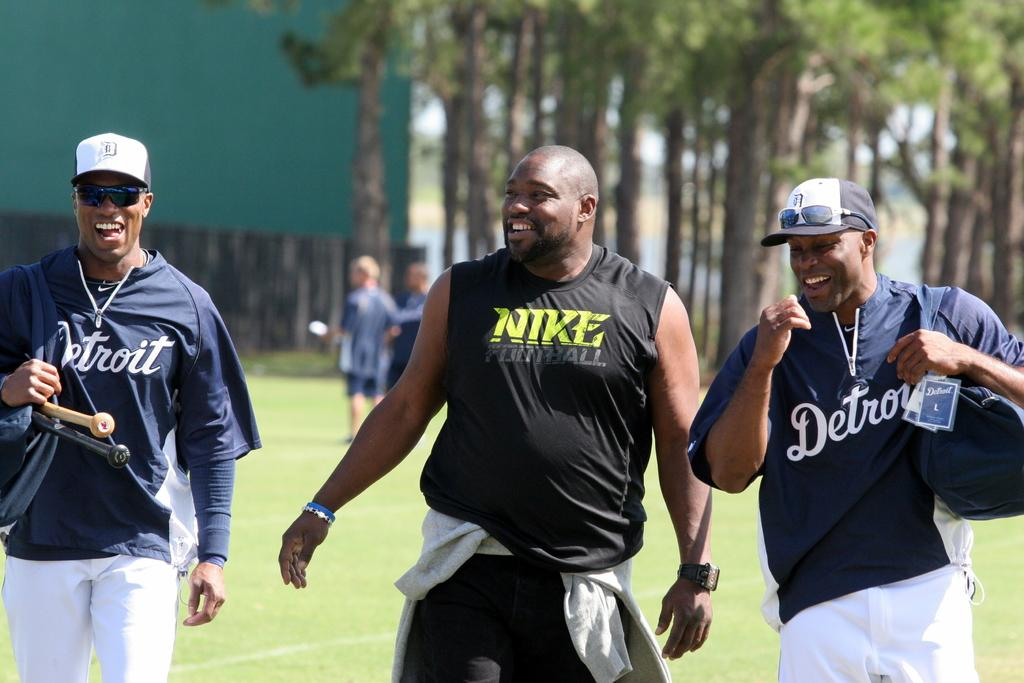<image>
Create a compact narrative representing the image presented. Three guys walking on grass and the middle one is wearing a shirt that says Nike. 